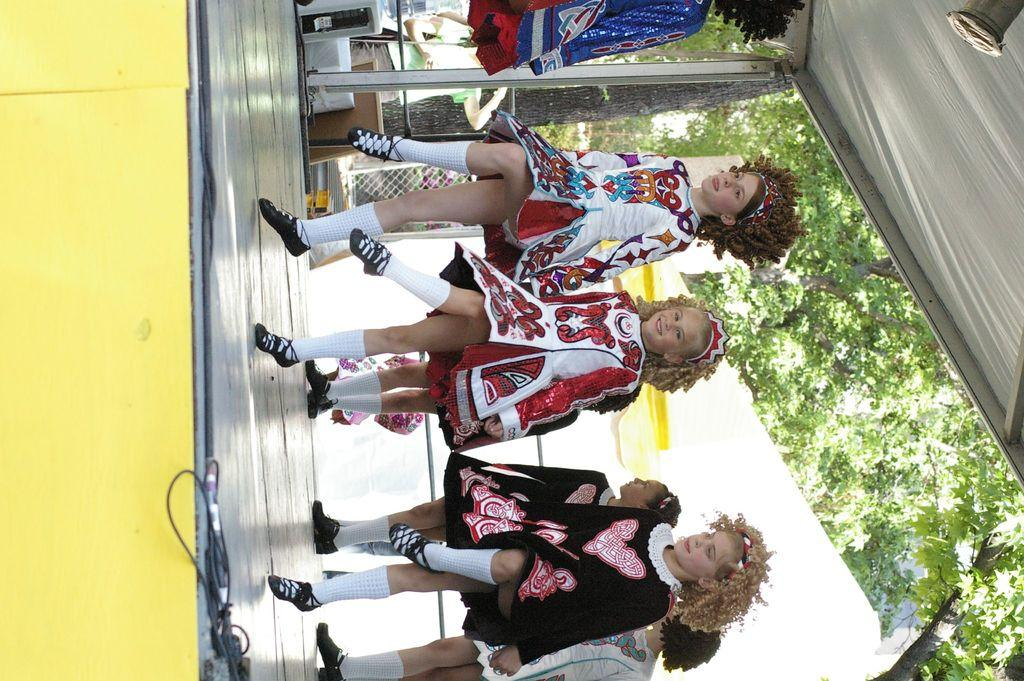What is happening in the image involving a group of children? There is a group of children in the image, and they are dancing on a stage. What can be seen on the right side of the image? There are trees on the right side of the image. What type of slave is depicted in the image? There is no depiction of a slave in the image; it features a group of children dancing on a stage. 